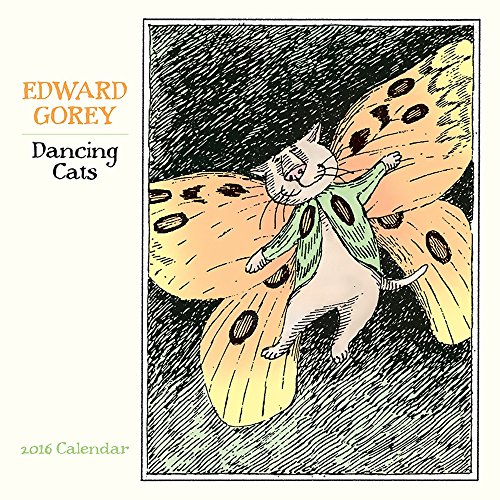Who wrote this book?
Answer the question using a single word or phrase. Edward Gorey What is the title of this book? Dancing Cats 2016 Calendar What type of book is this? Calendars Is this book related to Calendars? Yes Is this book related to Arts & Photography? No Which year's calendar is this? 2016 